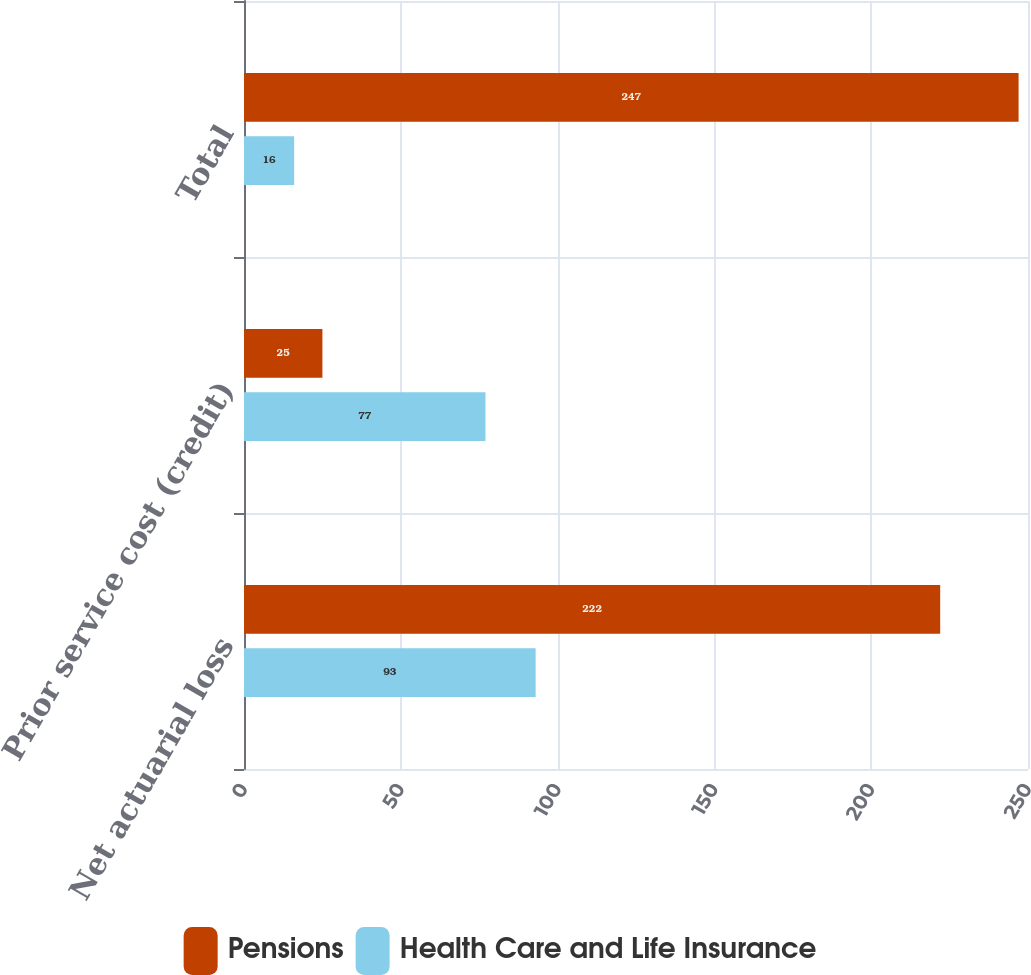<chart> <loc_0><loc_0><loc_500><loc_500><stacked_bar_chart><ecel><fcel>Net actuarial loss<fcel>Prior service cost (credit)<fcel>Total<nl><fcel>Pensions<fcel>222<fcel>25<fcel>247<nl><fcel>Health Care and Life Insurance<fcel>93<fcel>77<fcel>16<nl></chart> 